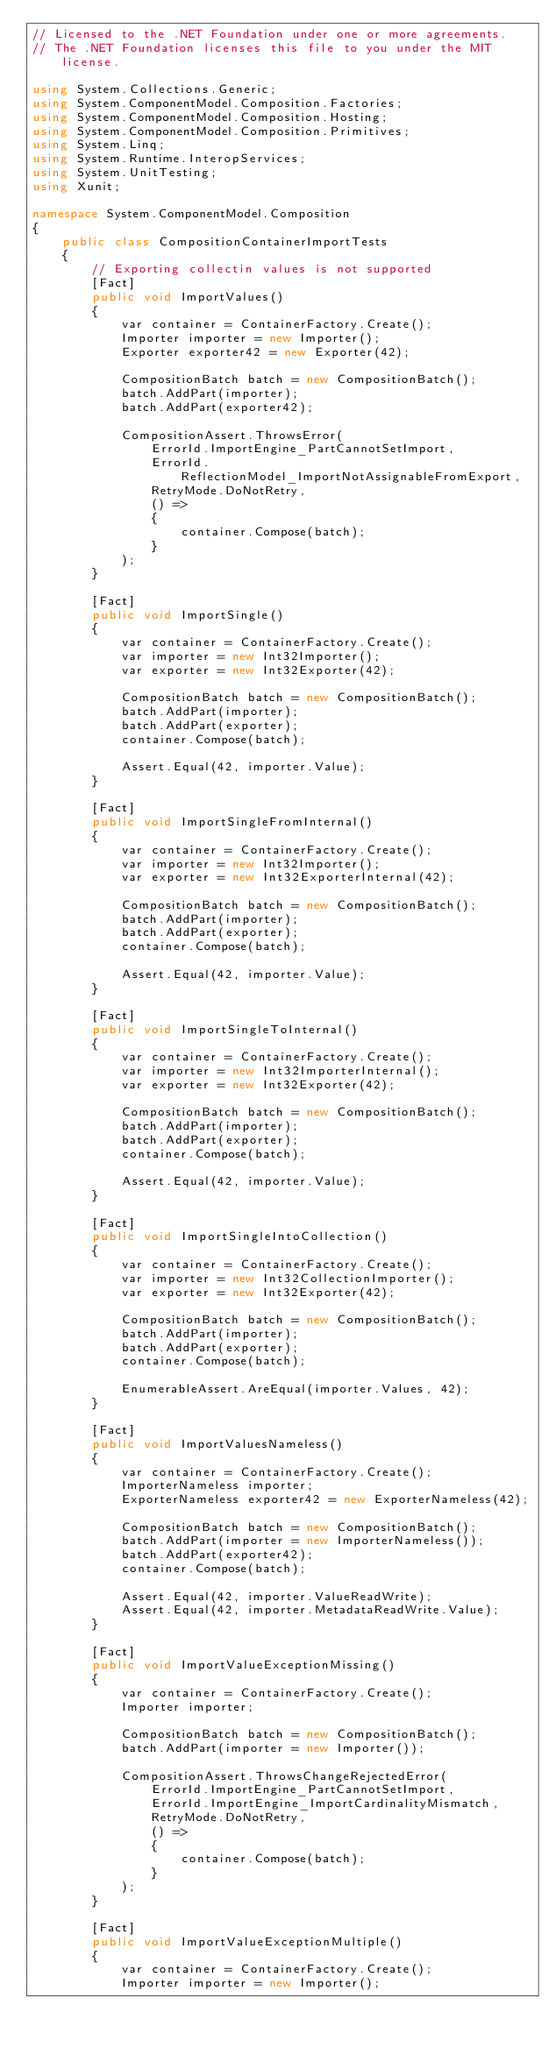<code> <loc_0><loc_0><loc_500><loc_500><_C#_>// Licensed to the .NET Foundation under one or more agreements.
// The .NET Foundation licenses this file to you under the MIT license.

using System.Collections.Generic;
using System.ComponentModel.Composition.Factories;
using System.ComponentModel.Composition.Hosting;
using System.ComponentModel.Composition.Primitives;
using System.Linq;
using System.Runtime.InteropServices;
using System.UnitTesting;
using Xunit;

namespace System.ComponentModel.Composition
{
    public class CompositionContainerImportTests
    {
        // Exporting collectin values is not supported
        [Fact]
        public void ImportValues()
        {
            var container = ContainerFactory.Create();
            Importer importer = new Importer();
            Exporter exporter42 = new Exporter(42);

            CompositionBatch batch = new CompositionBatch();
            batch.AddPart(importer);
            batch.AddPart(exporter42);

            CompositionAssert.ThrowsError(
                ErrorId.ImportEngine_PartCannotSetImport,
                ErrorId.ReflectionModel_ImportNotAssignableFromExport,
                RetryMode.DoNotRetry,
                () =>
                {
                    container.Compose(batch);
                }
            );
        }

        [Fact]
        public void ImportSingle()
        {
            var container = ContainerFactory.Create();
            var importer = new Int32Importer();
            var exporter = new Int32Exporter(42);

            CompositionBatch batch = new CompositionBatch();
            batch.AddPart(importer);
            batch.AddPart(exporter);
            container.Compose(batch);

            Assert.Equal(42, importer.Value);
        }

        [Fact]
        public void ImportSingleFromInternal()
        {
            var container = ContainerFactory.Create();
            var importer = new Int32Importer();
            var exporter = new Int32ExporterInternal(42);

            CompositionBatch batch = new CompositionBatch();
            batch.AddPart(importer);
            batch.AddPart(exporter);
            container.Compose(batch);

            Assert.Equal(42, importer.Value);
        }

        [Fact]
        public void ImportSingleToInternal()
        {
            var container = ContainerFactory.Create();
            var importer = new Int32ImporterInternal();
            var exporter = new Int32Exporter(42);

            CompositionBatch batch = new CompositionBatch();
            batch.AddPart(importer);
            batch.AddPart(exporter);
            container.Compose(batch);

            Assert.Equal(42, importer.Value);
        }

        [Fact]
        public void ImportSingleIntoCollection()
        {
            var container = ContainerFactory.Create();
            var importer = new Int32CollectionImporter();
            var exporter = new Int32Exporter(42);

            CompositionBatch batch = new CompositionBatch();
            batch.AddPart(importer);
            batch.AddPart(exporter);
            container.Compose(batch);

            EnumerableAssert.AreEqual(importer.Values, 42);
        }

        [Fact]
        public void ImportValuesNameless()
        {
            var container = ContainerFactory.Create();
            ImporterNameless importer;
            ExporterNameless exporter42 = new ExporterNameless(42);

            CompositionBatch batch = new CompositionBatch();
            batch.AddPart(importer = new ImporterNameless());
            batch.AddPart(exporter42);
            container.Compose(batch);

            Assert.Equal(42, importer.ValueReadWrite);
            Assert.Equal(42, importer.MetadataReadWrite.Value);
        }

        [Fact]
        public void ImportValueExceptionMissing()
        {
            var container = ContainerFactory.Create();
            Importer importer;

            CompositionBatch batch = new CompositionBatch();
            batch.AddPart(importer = new Importer());

            CompositionAssert.ThrowsChangeRejectedError(
                ErrorId.ImportEngine_PartCannotSetImport,
                ErrorId.ImportEngine_ImportCardinalityMismatch,
                RetryMode.DoNotRetry,
                () =>
                {
                    container.Compose(batch);
                }
            );
        }

        [Fact]
        public void ImportValueExceptionMultiple()
        {
            var container = ContainerFactory.Create();
            Importer importer = new Importer();</code> 